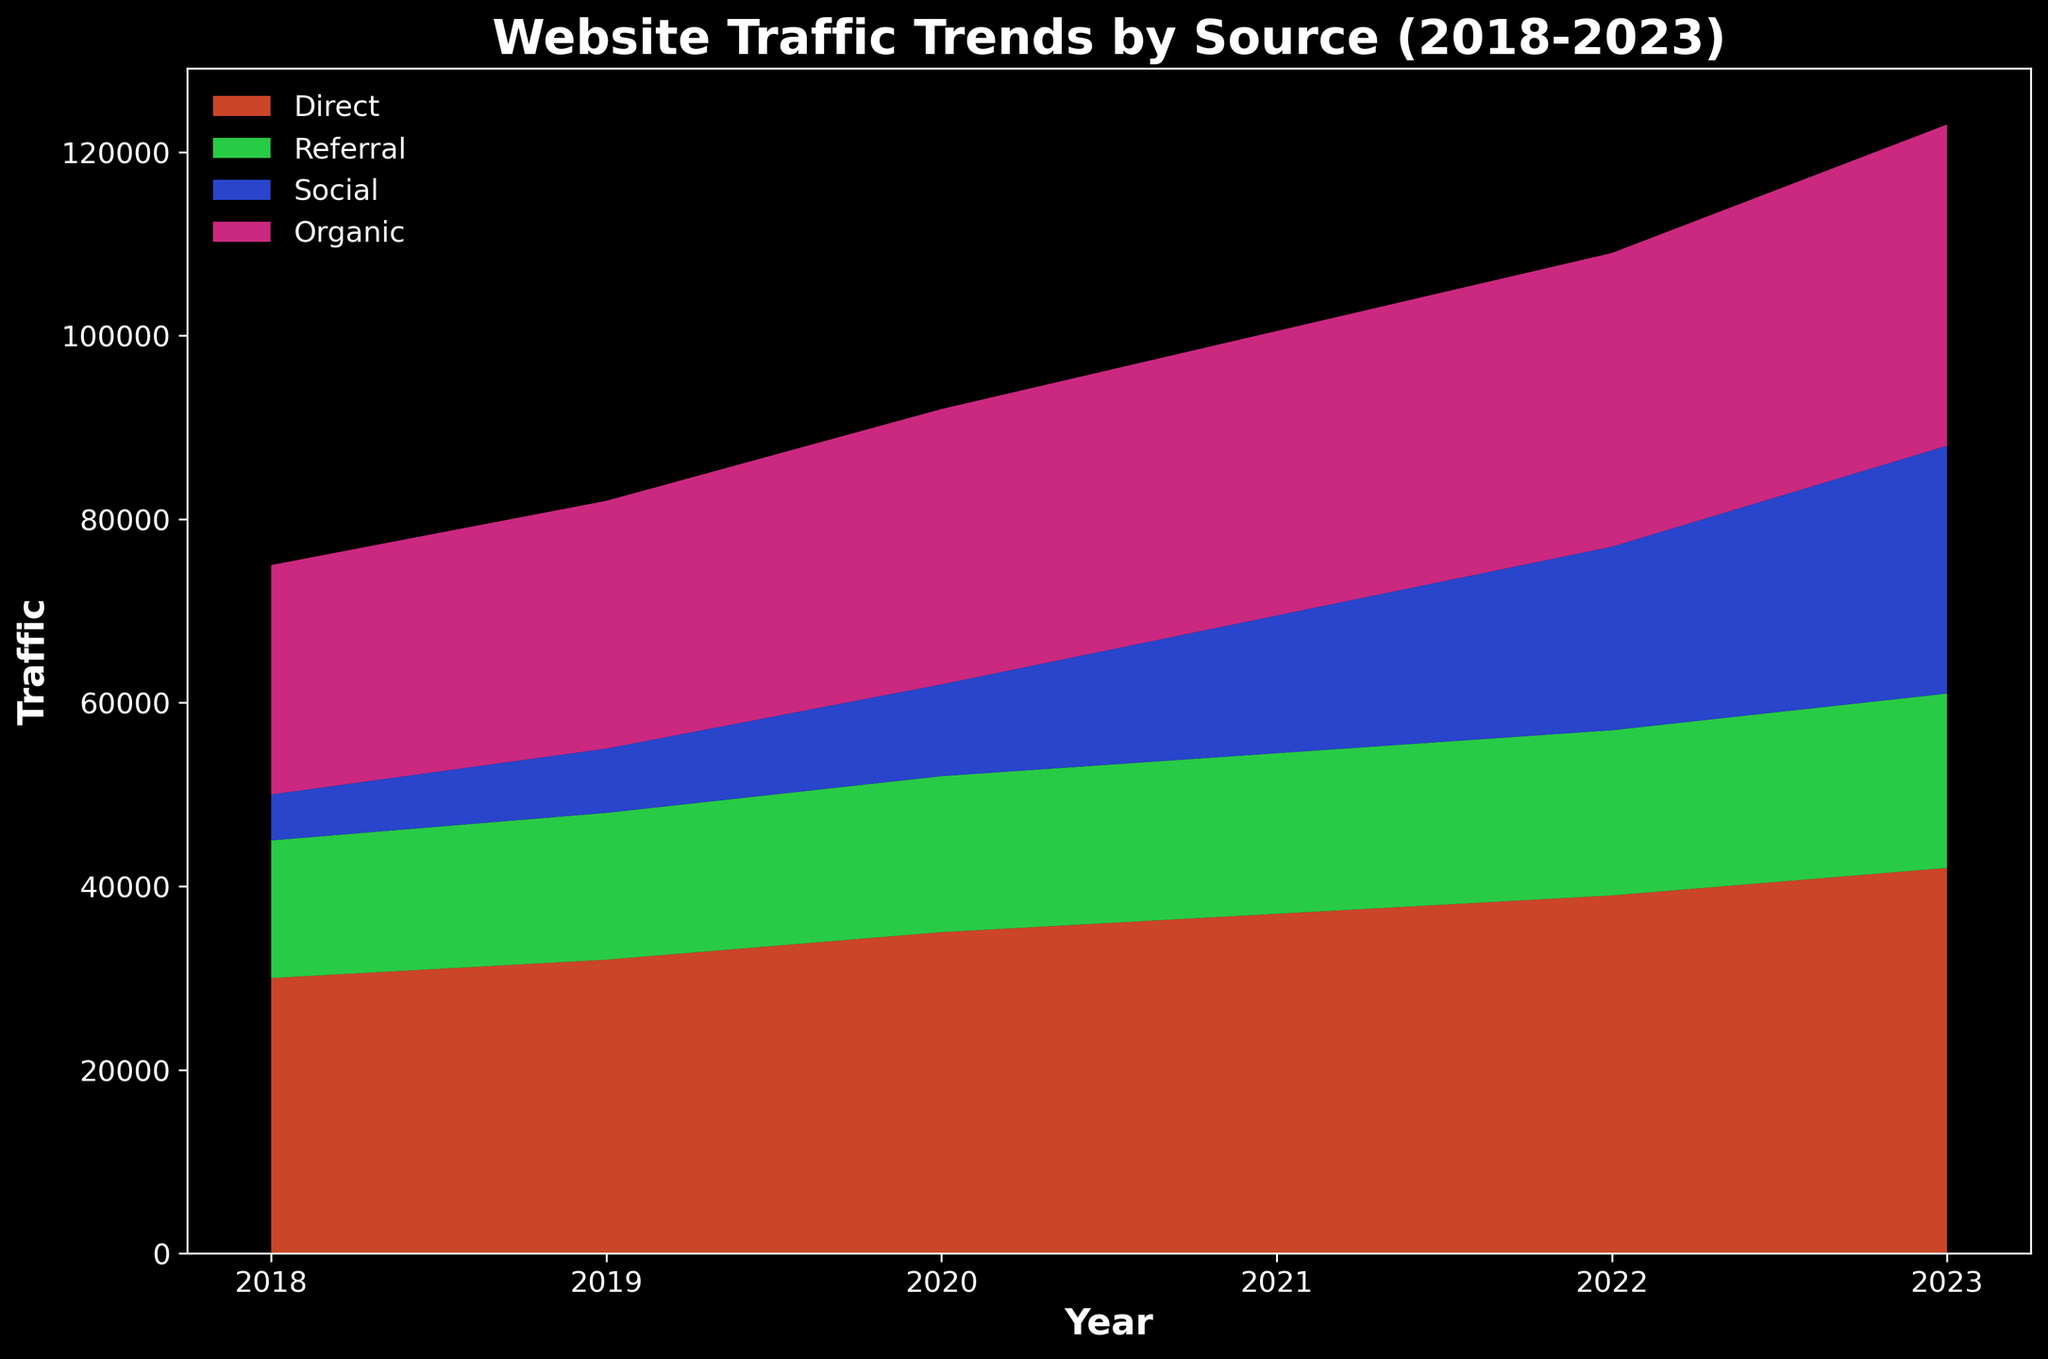How has the traffic from Direct sources changed from 2018 to 2023? Look at the Direct traffic values for each year and compare 2018 (30,000) to 2023 (42,000). The traffic has increased.
Answer: Increased Which source showed the most significant increase in traffic over the five-year period? Compare the increase in traffic for each source: Direct (12,000), Referral (4,000), Social (22,000), Organic (10,000). Social has the largest increase.
Answer: Social What is the total traffic from all sources in 2023? Sum up the traffic from all sources in 2023: Direct (42,000) + Referral (19,000) + Social (27,000) + Organic (35,000) = 123,000.
Answer: 123,000 Which year had the highest total website traffic? Add up the traffic from all sources for each year. The year with the highest total is 2023 with 123,000.
Answer: 2023 Between Organic and Referral, which source consistently had more traffic? Compare the traffic of Organic and Referral for each year. Organic is consistently higher every year.
Answer: Organic How much did the Social traffic increase by in 2022 compared to 2021? Subtract the Social traffic in 2021 (15,000) from the Social traffic in 2022 (20,000), which results in an increase of 5,000.
Answer: 5,000 In which year did Referral traffic surpass 17,000 for the first time? Look at the Referral traffic for each year. Referral traffic first surpasses 17,000 in 2021.
Answer: 2021 Which source's traffic showed the least amount of fluctuation over the five years? Observe each source's trend. Referral traffic changes the least over the five years.
Answer: Referral Examine the color representing the Social traffic; How has its relative area changed from 2019 to 2023? The color representing Social traffic is a bright pink. The area related to Social traffic grows noticeably from a small initial portion to a larger portion over the years.
Answer: Increased What is the difference in the traffic growth rates between Direct and Organic sources from 2018 to 2023? Calculate the growth for Direct (42,000 - 30,000 = 12,000) and Organic (35,000 - 25,000 = 10,000). The difference is 2,000.
Answer: 2,000 